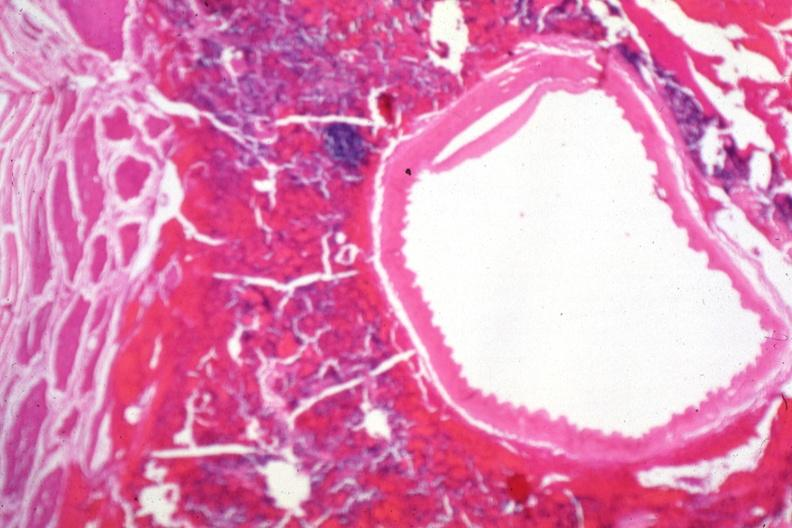s endocrine present?
Answer the question using a single word or phrase. Yes 